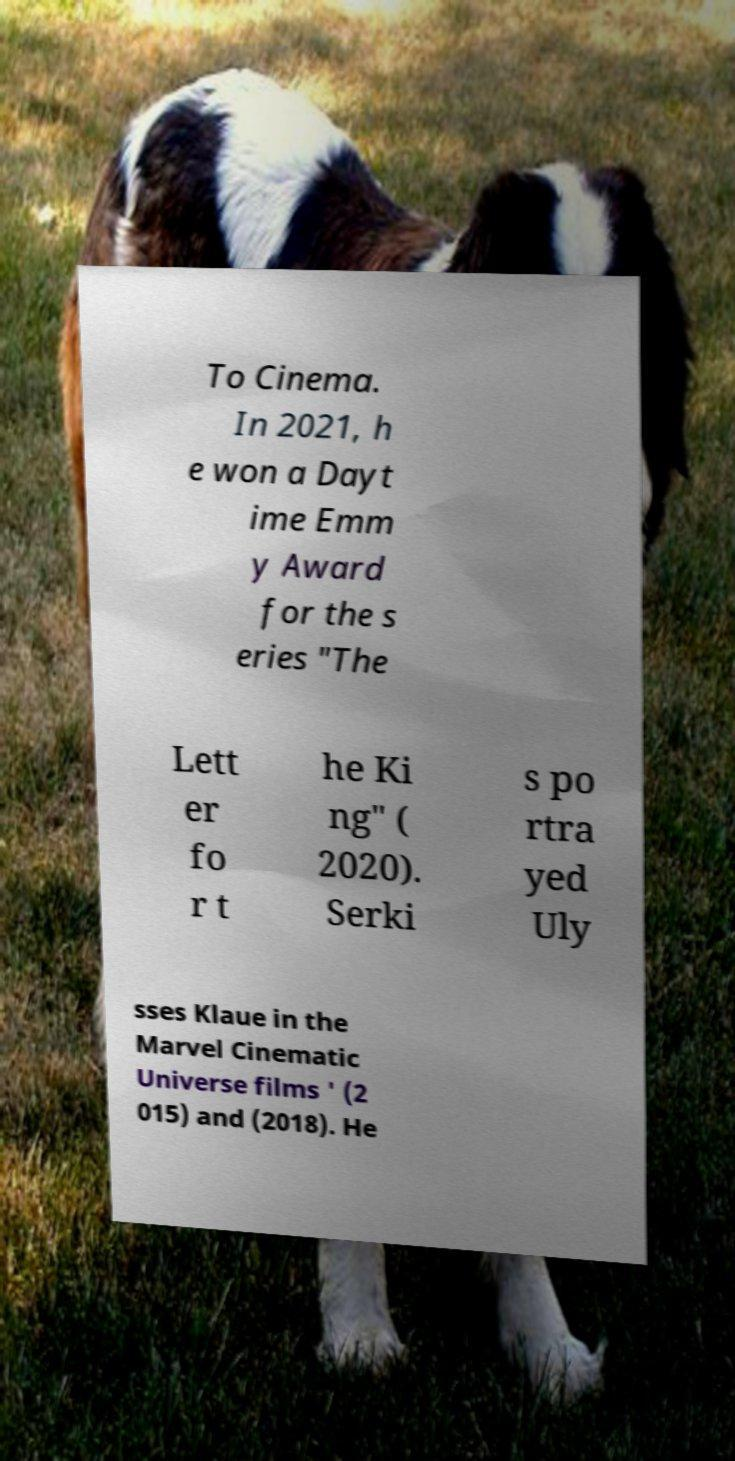For documentation purposes, I need the text within this image transcribed. Could you provide that? To Cinema. In 2021, h e won a Dayt ime Emm y Award for the s eries "The Lett er fo r t he Ki ng" ( 2020). Serki s po rtra yed Uly sses Klaue in the Marvel Cinematic Universe films ' (2 015) and (2018). He 